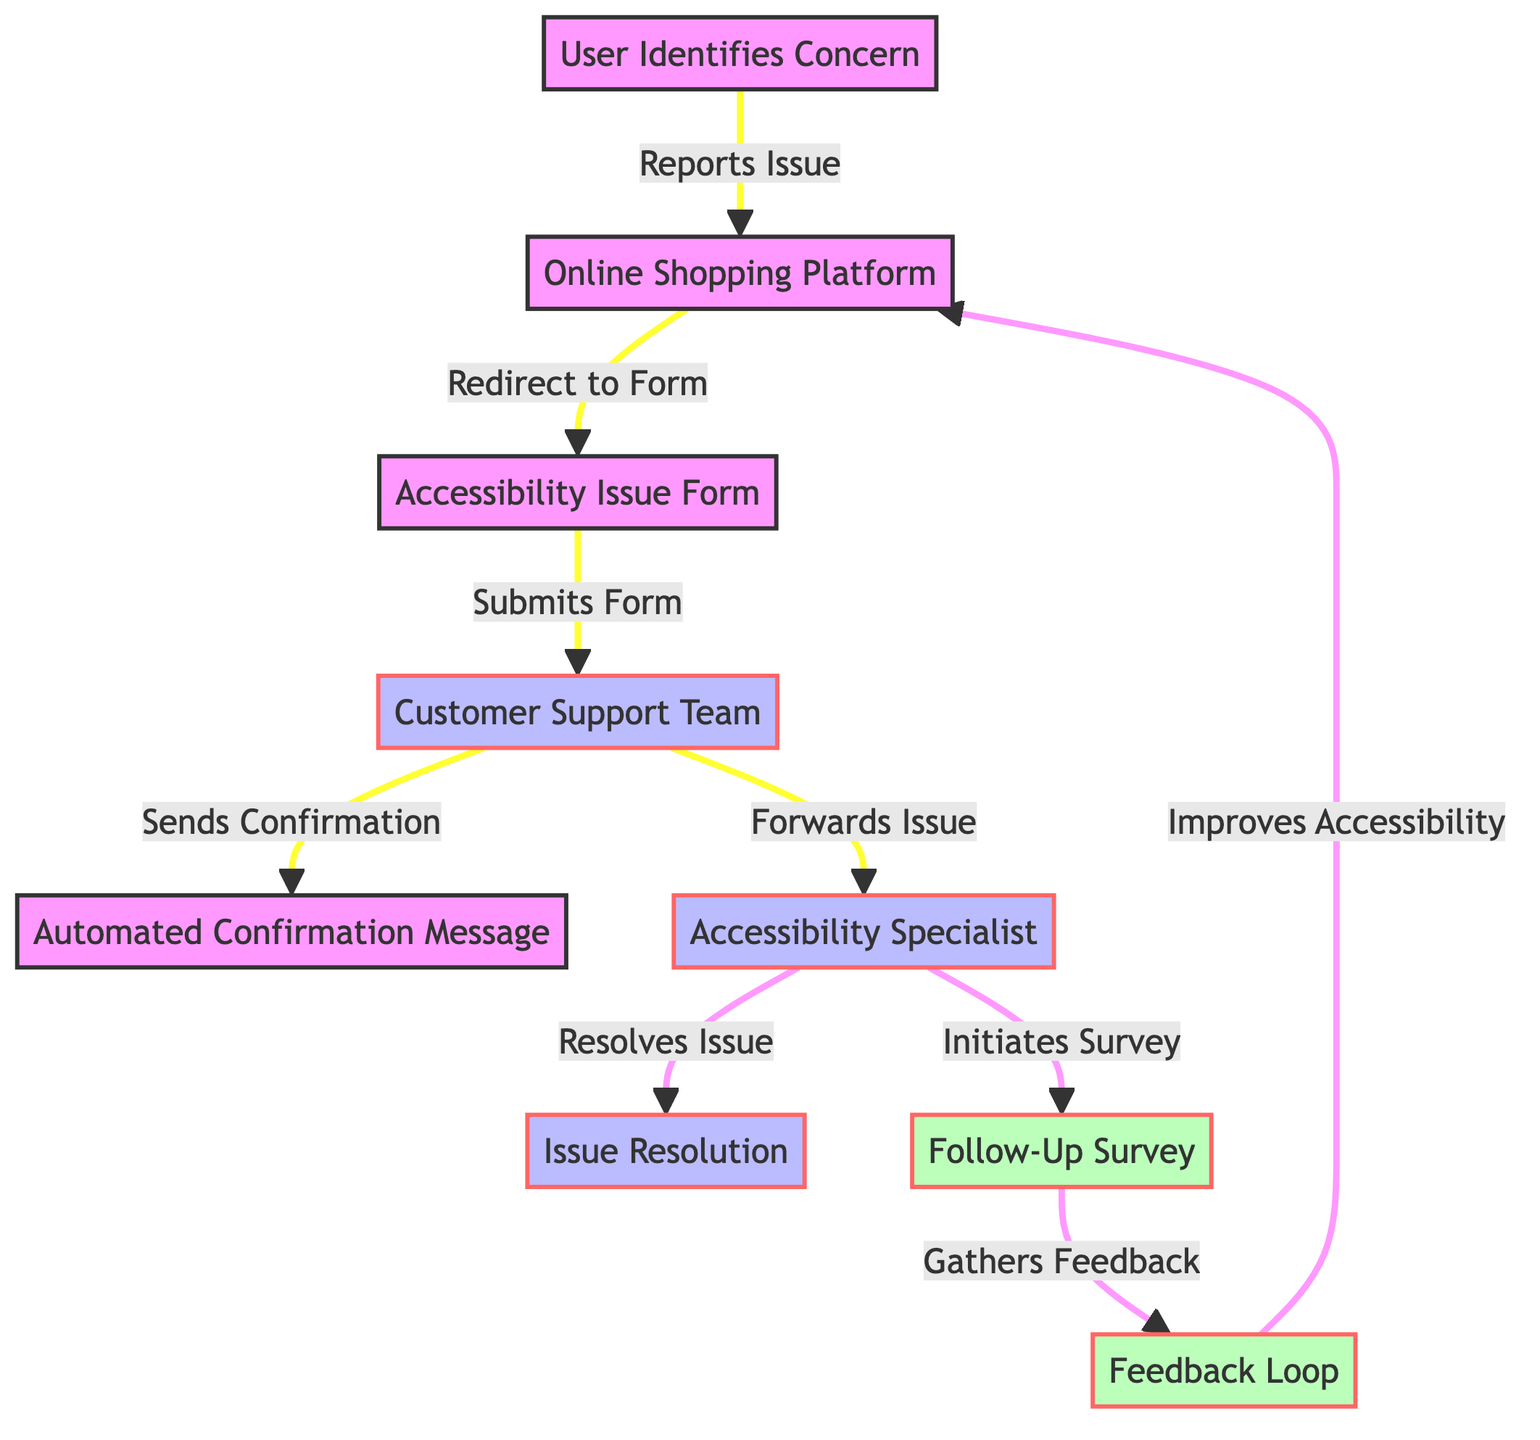What is the total number of nodes in the diagram? The diagram lists 9 distinct entities, which are represented as nodes. Counting each node: User Identifies Concern, Online Shopping Platform, Accessibility Issue Form, Customer Support Team, Automated Confirmation Message, Accessibility Specialist, Issue Resolution, Follow-Up Survey, and Feedback Loop gives a total of 9.
Answer: 9 What is the relationship between "Accessibility Specialist" and "Issue Resolution"? According to the arrows, the Accessibility Specialist directly connects to Issue Resolution, indicating that the Accessibility Specialist is responsible for resolving the issue that has been reported.
Answer: Resolves Issue What is the first action taken by the user? The starting node is "User Identifies Concern," which signifies that the user's first action is to identify a concern regarding accessibility. This initiates the process.
Answer: User Identifies Concern How many edges are connected to "Customer Support Team"? By examining the connections leading to and from the Customer Support Team, two outgoing edges can be identified: one leading to the Automated Confirmation Message and another leading to the Accessibility Specialist, resulting in a total of 2 outgoing edges.
Answer: 2 What is the final outcome of the feedback loop in the diagram? The feedback loop indicates that the final outcome of the process is improvements made to the accessibility of the Online Shopping Platform, showing that user input leads to enhancements in services provided.
Answer: Improves Accessibility What action follows the sending of the automated confirmation message? After the Customer Support Team sends the confirmation message, they forward the issue to the Accessibility Specialist. Thus, the next step in the process following the Automated Confirmation Message is forwarding the issue.
Answer: Forwards Issue Which node is responsible for gathering feedback? The Follow-Up Survey, as indicated in the diagram, is specifically tasked with gathering feedback from users to understand their experience regarding the accessibility issue.
Answer: Follow-Up Survey How does the flow of the diagram improve the shopping platform? The diagram illustrates that feedback collected through the Follow-Up Survey is ultimately used to improve the accessibility of the Online Shopping Platform, showcasing a continuous process aimed at enhancement.
Answer: Improves Accessibility What role does the Automated Confirmation Message play in the process? The Automated Confirmation Message serves as a notification to the user, confirming that their reported issue has been received by the Customer Support Team. It acts as an acknowledgment before further actions are taken.
Answer: Sends Confirmation 